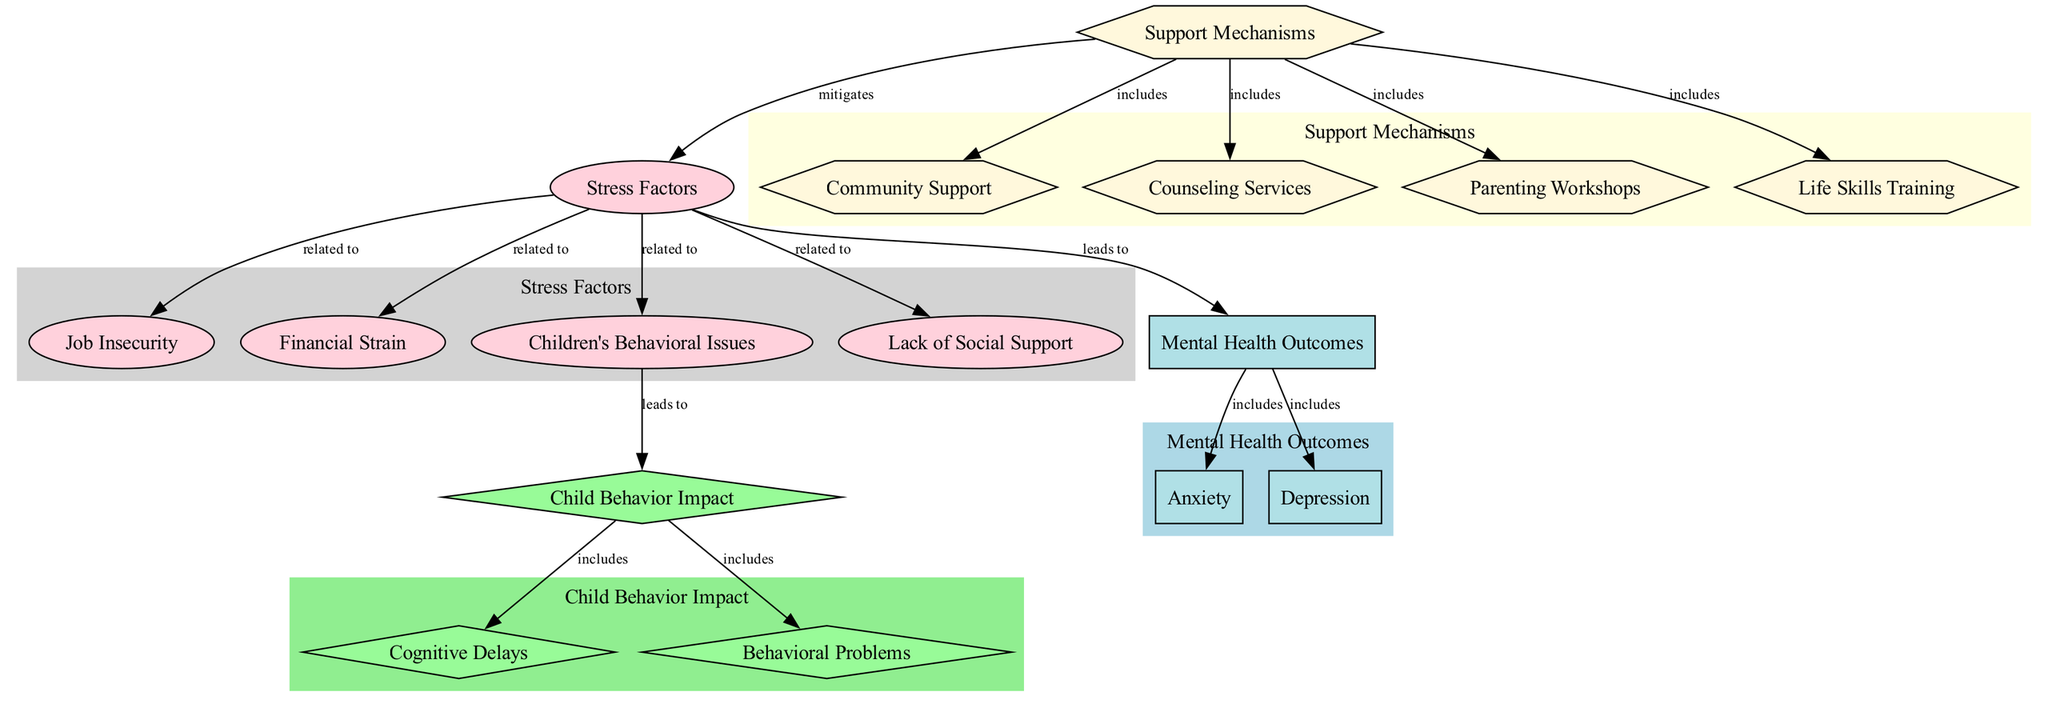What are the Stress Factors identified in the diagram? The nodes categorized under "Stress" include Job Insecurity, Financial Strain, Children's Behavioral Issues, and Lack of Social Support. These are specifically listed under the "Stress Factors" node.
Answer: Job Insecurity, Financial Strain, Children's Behavioral Issues, Lack of Social Support How many Mental Health Outcomes are listed in the diagram? There are two outcomes related to mental health: Anxiety and Depression. This can be counted directly from the nodes under "Mental Health."
Answer: 2 Which stress factor leads to Mental Health Outcomes? The edge connecting the "stress_factors" node to the "mental_health_outcomes" node indicates that Stress Factors lead to Mental Health Outcomes.
Answer: Stress Factors What are the impacts of Children's Behavioral Issues? The "children_behavioral_issues" node leads to "child_behavior_impact," which further leads to Cognitive Delays and Behavioral Problems. This information is derived from the connections stemming from the "children_behavioral_issues" node.
Answer: Cognitive Delays, Behavioral Problems Which support mechanism mitigates the stress factors? The edge from the "support_mechanisms" node to the "stress_factors" node indicates this relationship, demonstrating that the support mechanisms help reduce the impact of stress factors on mothers and children.
Answer: Support Mechanisms What are the types of Support Mechanisms mentioned in the diagram? The support mechanisms include Community Support, Counseling Services, Parenting Workshops, and Life Skills Training, as they are under the "Support" group and directly linked to the "support_mechanisms" node.
Answer: Community Support, Counseling Services, Parenting Workshops, Life Skills Training How does Child Behavior Impact affect child well-being? The "child_behavior_impact" node leads to both "cognitive_delays" and "behavioral_problems," which indicates that the impact on child behavior has multiple negative outcomes influencing child well-being.
Answer: Cognitive Delays, Behavioral Problems What is included in Mental Health Outcomes? The "mental_health_outcomes" node connects to both Anxiety and Depression, suggesting that these are key components of mental health outcomes experienced by single mothers.
Answer: Anxiety, Depression 